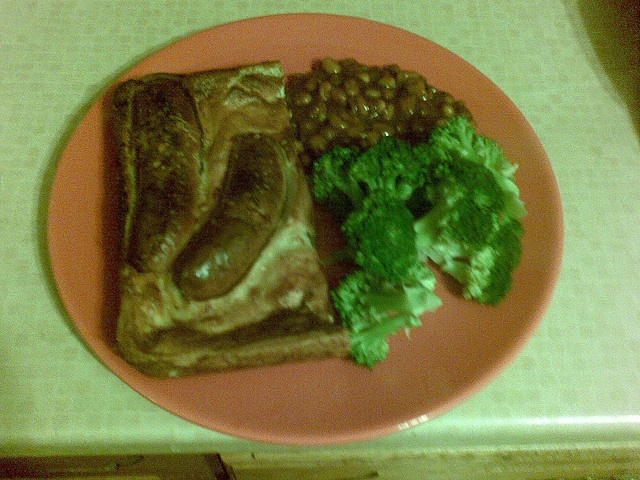Describe the objects in this image and their specific colors. I can see dining table in olive, lightgreen, and black tones and broccoli in tan, darkgreen, black, and green tones in this image. 